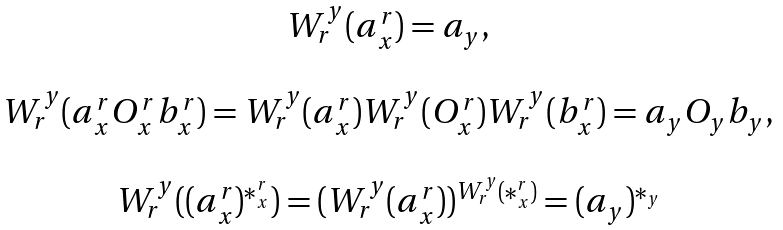Convert formula to latex. <formula><loc_0><loc_0><loc_500><loc_500>\begin{array} { c } W ^ { y } _ { r } ( a ^ { r } _ { x } ) = a _ { y } , \\ \\ W ^ { y } _ { r } ( a ^ { r } _ { x } O ^ { r } _ { x } b ^ { r } _ { x } ) = W ^ { y } _ { r } ( a ^ { r } _ { x } ) W ^ { y } _ { r } ( O ^ { r } _ { x } ) W ^ { y } _ { r } ( b ^ { r } _ { x } ) = a _ { y } O _ { y } b _ { y } , \\ \\ W ^ { y } _ { r } ( ( a ^ { r } _ { x } ) ^ { * ^ { r } _ { x } } ) = ( W ^ { y } _ { r } ( a ^ { r } _ { x } ) ) ^ { W ^ { y } _ { r } ( * ^ { r } _ { x } ) } = ( a _ { y } ) ^ { * _ { y } } \end{array}</formula> 